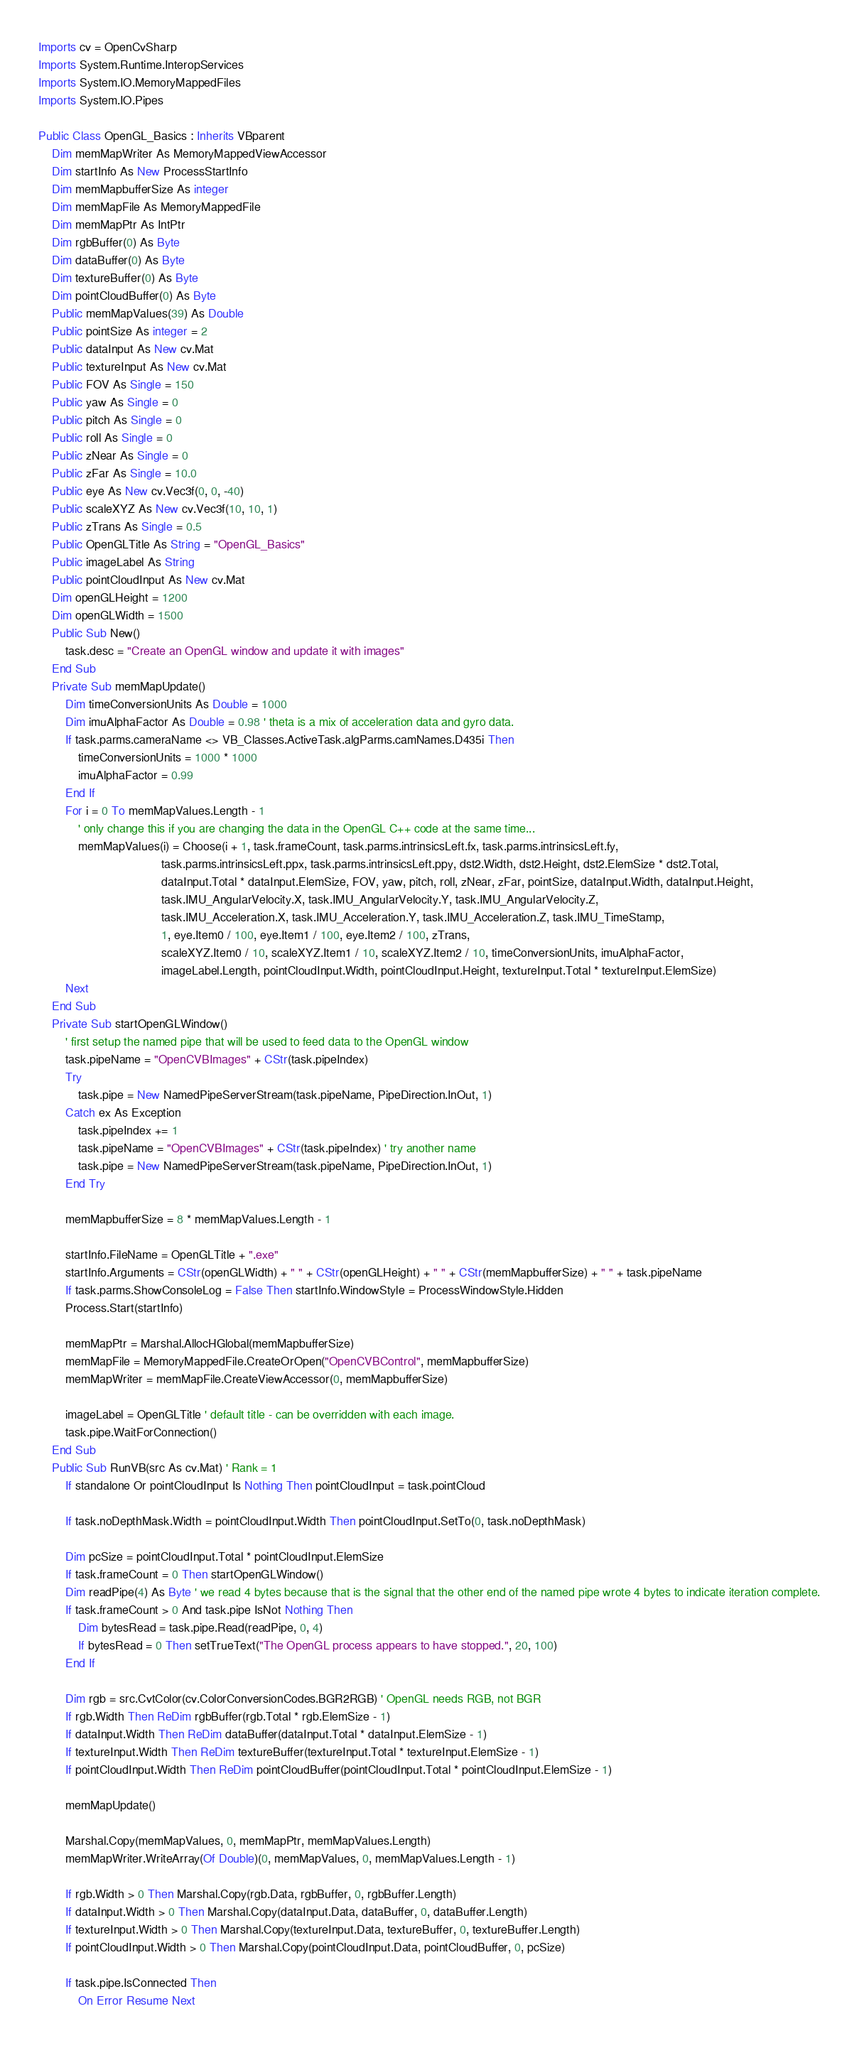Convert code to text. <code><loc_0><loc_0><loc_500><loc_500><_VisualBasic_>Imports cv = OpenCvSharp
Imports System.Runtime.InteropServices
Imports System.IO.MemoryMappedFiles
Imports System.IO.Pipes

Public Class OpenGL_Basics : Inherits VBparent
    Dim memMapWriter As MemoryMappedViewAccessor
    Dim startInfo As New ProcessStartInfo
    Dim memMapbufferSize As integer
    Dim memMapFile As MemoryMappedFile
    Dim memMapPtr As IntPtr
    Dim rgbBuffer(0) As Byte
    Dim dataBuffer(0) As Byte
    Dim textureBuffer(0) As Byte
    Dim pointCloudBuffer(0) As Byte
    Public memMapValues(39) As Double
    Public pointSize As integer = 2
    Public dataInput As New cv.Mat
    Public textureInput As New cv.Mat
    Public FOV As Single = 150
    Public yaw As Single = 0
    Public pitch As Single = 0
    Public roll As Single = 0
    Public zNear As Single = 0
    Public zFar As Single = 10.0
    Public eye As New cv.Vec3f(0, 0, -40)
    Public scaleXYZ As New cv.Vec3f(10, 10, 1)
    Public zTrans As Single = 0.5
    Public OpenGLTitle As String = "OpenGL_Basics"
    Public imageLabel As String
    Public pointCloudInput As New cv.Mat
    Dim openGLHeight = 1200
    Dim openGLWidth = 1500
    Public Sub New()
        task.desc = "Create an OpenGL window and update it with images"
    End Sub
    Private Sub memMapUpdate()
        Dim timeConversionUnits As Double = 1000
        Dim imuAlphaFactor As Double = 0.98 ' theta is a mix of acceleration data and gyro data.
        If task.parms.cameraName <> VB_Classes.ActiveTask.algParms.camNames.D435i Then
            timeConversionUnits = 1000 * 1000
            imuAlphaFactor = 0.99
        End If
        For i = 0 To memMapValues.Length - 1
            ' only change this if you are changing the data in the OpenGL C++ code at the same time...
            memMapValues(i) = Choose(i + 1, task.frameCount, task.parms.intrinsicsLeft.fx, task.parms.intrinsicsLeft.fy,
                                     task.parms.intrinsicsLeft.ppx, task.parms.intrinsicsLeft.ppy, dst2.Width, dst2.Height, dst2.ElemSize * dst2.Total,
                                     dataInput.Total * dataInput.ElemSize, FOV, yaw, pitch, roll, zNear, zFar, pointSize, dataInput.Width, dataInput.Height,
                                     task.IMU_AngularVelocity.X, task.IMU_AngularVelocity.Y, task.IMU_AngularVelocity.Z,
                                     task.IMU_Acceleration.X, task.IMU_Acceleration.Y, task.IMU_Acceleration.Z, task.IMU_TimeStamp,
                                     1, eye.Item0 / 100, eye.Item1 / 100, eye.Item2 / 100, zTrans,
                                     scaleXYZ.Item0 / 10, scaleXYZ.Item1 / 10, scaleXYZ.Item2 / 10, timeConversionUnits, imuAlphaFactor,
                                     imageLabel.Length, pointCloudInput.Width, pointCloudInput.Height, textureInput.Total * textureInput.ElemSize)
        Next
    End Sub
    Private Sub startOpenGLWindow()
        ' first setup the named pipe that will be used to feed data to the OpenGL window
        task.pipeName = "OpenCVBImages" + CStr(task.pipeIndex)
        Try
            task.pipe = New NamedPipeServerStream(task.pipeName, PipeDirection.InOut, 1)
        Catch ex As Exception
            task.pipeIndex += 1
            task.pipeName = "OpenCVBImages" + CStr(task.pipeIndex) ' try another name 
            task.pipe = New NamedPipeServerStream(task.pipeName, PipeDirection.InOut, 1)
        End Try

        memMapbufferSize = 8 * memMapValues.Length - 1

        startInfo.FileName = OpenGLTitle + ".exe"
        startInfo.Arguments = CStr(openGLWidth) + " " + CStr(openGLHeight) + " " + CStr(memMapbufferSize) + " " + task.pipeName
        If task.parms.ShowConsoleLog = False Then startInfo.WindowStyle = ProcessWindowStyle.Hidden
        Process.Start(startInfo)

        memMapPtr = Marshal.AllocHGlobal(memMapbufferSize)
        memMapFile = MemoryMappedFile.CreateOrOpen("OpenCVBControl", memMapbufferSize)
        memMapWriter = memMapFile.CreateViewAccessor(0, memMapbufferSize)

        imageLabel = OpenGLTitle ' default title - can be overridden with each image.
        task.pipe.WaitForConnection()
    End Sub
    Public Sub RunVB(src As cv.Mat) ' Rank = 1
        If standalone Or pointCloudInput Is Nothing Then pointCloudInput = task.pointCloud

        If task.noDepthMask.Width = pointCloudInput.Width Then pointCloudInput.SetTo(0, task.noDepthMask)

        Dim pcSize = pointCloudInput.Total * pointCloudInput.ElemSize
        If task.frameCount = 0 Then startOpenGLWindow()
        Dim readPipe(4) As Byte ' we read 4 bytes because that is the signal that the other end of the named pipe wrote 4 bytes to indicate iteration complete.
        If task.frameCount > 0 And task.pipe IsNot Nothing Then
            Dim bytesRead = task.pipe.Read(readPipe, 0, 4)
            If bytesRead = 0 Then setTrueText("The OpenGL process appears to have stopped.", 20, 100)
        End If

        Dim rgb = src.CvtColor(cv.ColorConversionCodes.BGR2RGB) ' OpenGL needs RGB, not BGR
        If rgb.Width Then ReDim rgbBuffer(rgb.Total * rgb.ElemSize - 1)
        If dataInput.Width Then ReDim dataBuffer(dataInput.Total * dataInput.ElemSize - 1)
        If textureInput.Width Then ReDim textureBuffer(textureInput.Total * textureInput.ElemSize - 1)
        If pointCloudInput.Width Then ReDim pointCloudBuffer(pointCloudInput.Total * pointCloudInput.ElemSize - 1)

        memMapUpdate()

        Marshal.Copy(memMapValues, 0, memMapPtr, memMapValues.Length)
        memMapWriter.WriteArray(Of Double)(0, memMapValues, 0, memMapValues.Length - 1)

        If rgb.Width > 0 Then Marshal.Copy(rgb.Data, rgbBuffer, 0, rgbBuffer.Length)
        If dataInput.Width > 0 Then Marshal.Copy(dataInput.Data, dataBuffer, 0, dataBuffer.Length)
        If textureInput.Width > 0 Then Marshal.Copy(textureInput.Data, textureBuffer, 0, textureBuffer.Length)
        If pointCloudInput.Width > 0 Then Marshal.Copy(pointCloudInput.Data, pointCloudBuffer, 0, pcSize)

        If task.pipe.IsConnected Then
            On Error Resume Next</code> 